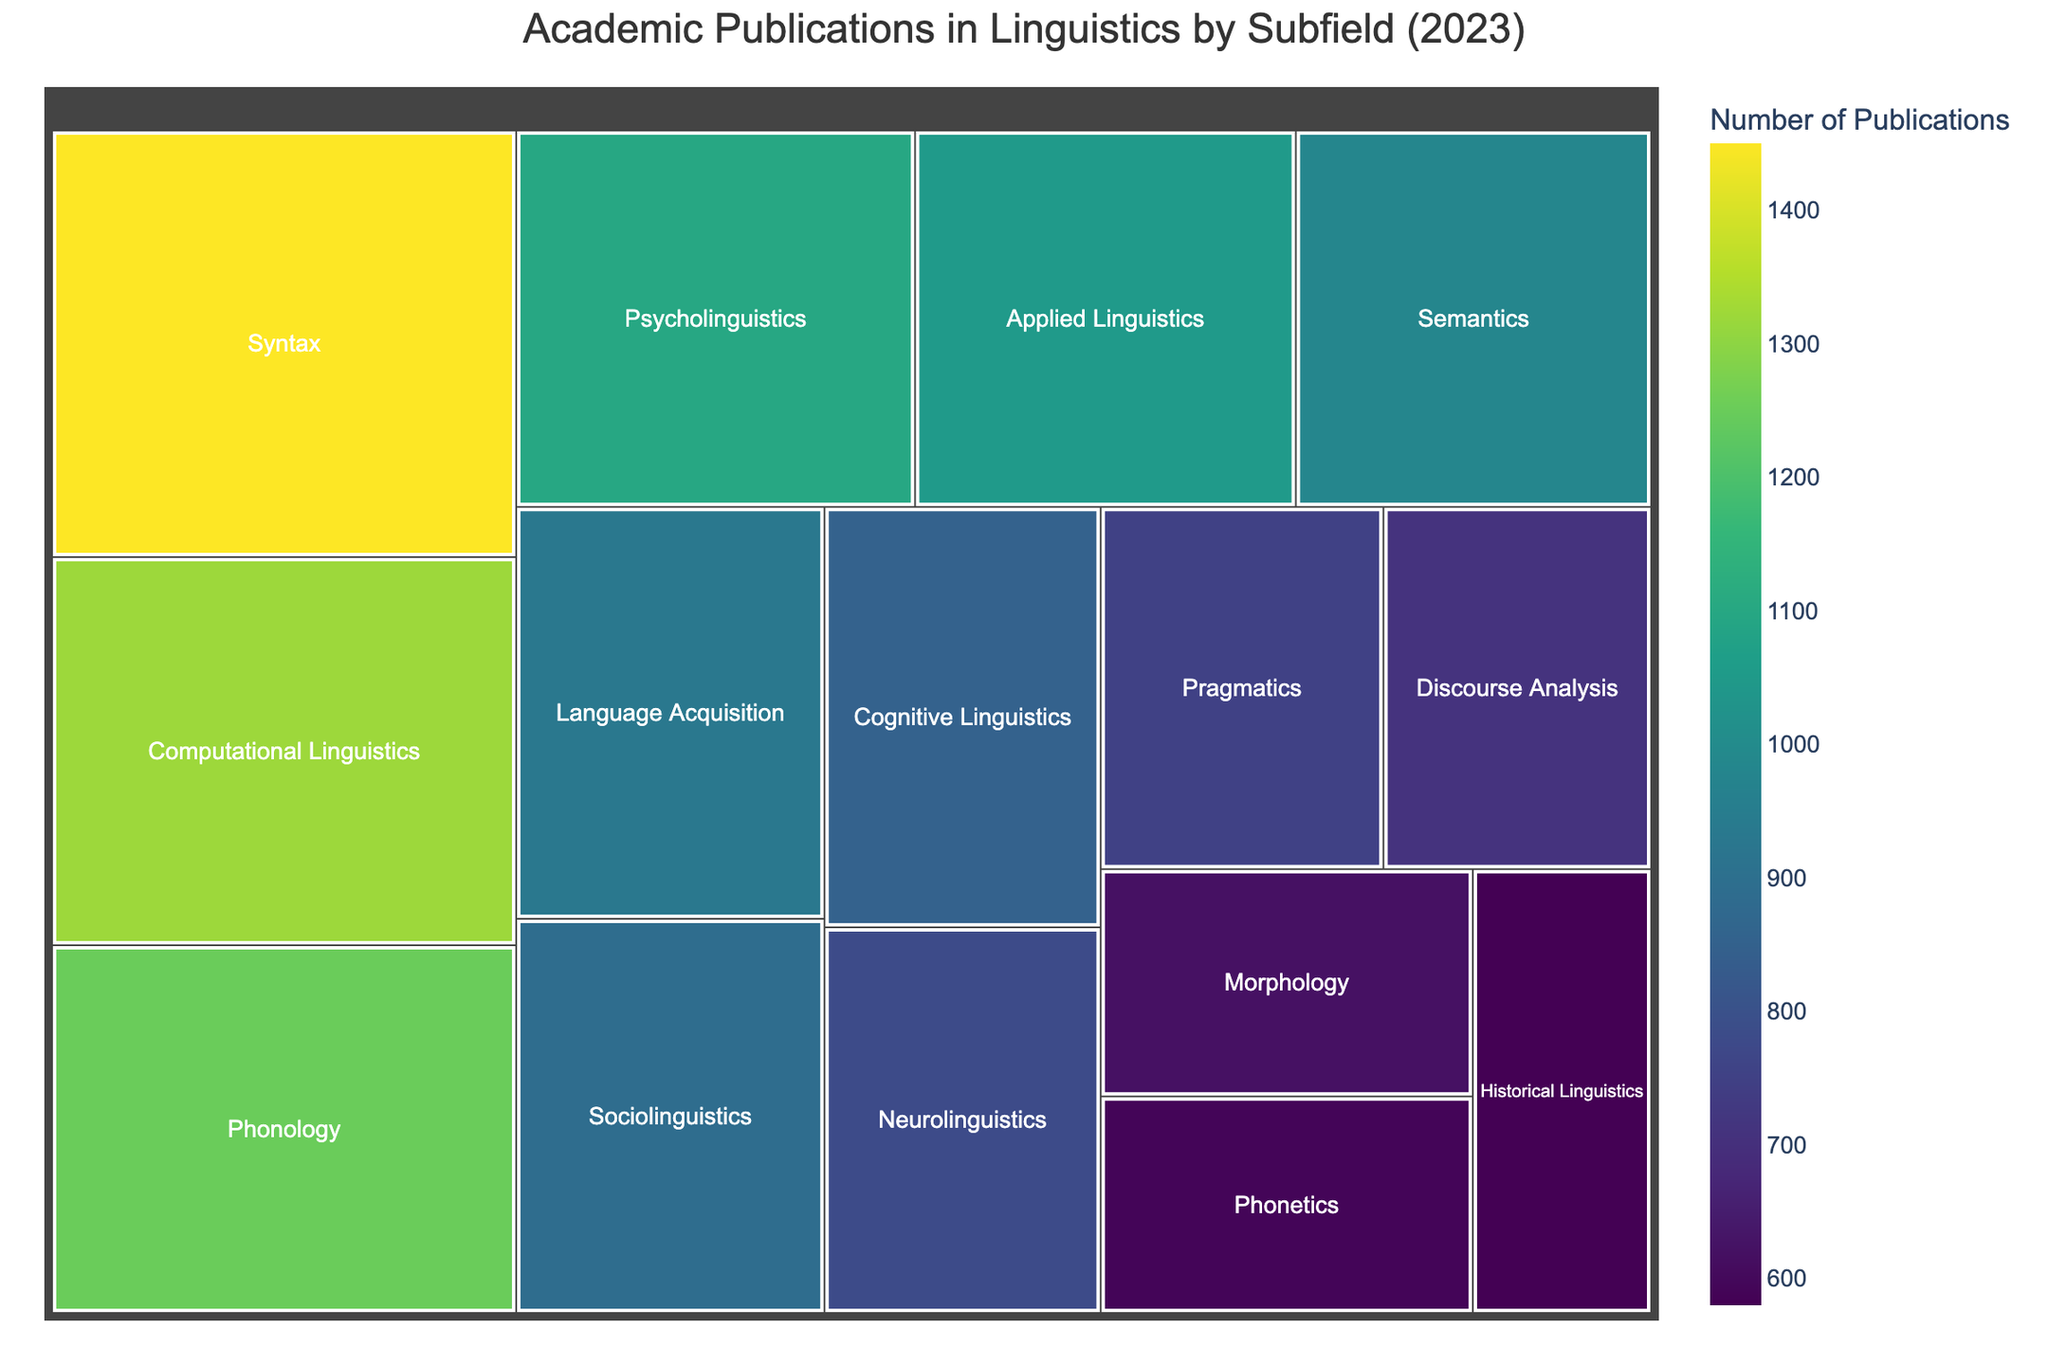what is the title of the figure? The title of the figure is indicated at the top of the treemap within the layout settings. It is written in larger font size to highlight it.
Answer: Academic Publications in Linguistics by Subfield (2023) how many publications does the Syntax subfield have? The number of publications per subfield is shown within each section of the treemap. For the Syntax subfield, this number is written on the block representing Syntax.
Answer: 1450 which subfield has the fewest publications? By inspecting the relative sizes of the blocks in the treemap, the subfield with the smallest block will have the fewest publications. This is identified as Historical Linguistics.
Answer: Historical Linguistics which subfield has more publications: Semantics or Pragmatics? By comparing the sizes and the number labels of the Semantics and Pragmatics blocks, we see that the Semantics subfield has 980 publications, whereas Pragmatics has 750 publications.
Answer: Semantics what is the total number of publications for Phonology, Syntax, and Semantics combined? Add the number of publications for Phonology (1250), Syntax (1450), and Semantics (980). (1250 + 1450 + 980) = 3680
Answer: 3680 which subfield has a greater number of publications: Computational Linguistics or Applied Linguistics? Inspect the size and labels of the blocks for the two subfields. Computational Linguistics has 1320 publications, while Applied Linguistics has 1050 publications.
Answer: Computational Linguistics what is the difference in the number of publications between Psycholinguistics and Neurolinguistics? Subtract the number of publications in Neurolinguistics (780) from those in Psycholinguistics (1100). (1100 - 780) = 320
Answer: 320 which subfield has close to 850 publications? Find the subfield blocks around 850 publications by checking the labels on the treemap and locating Cognitive Linguistics at 850 publications.
Answer: Cognitive Linguistics how does the size of the Pragmatics block compare to the Discourse Analysis block? Compare the publication numbers: Pragmatics has 750 and Discourse Analysis has 710. Pragmatics is slightly larger than Discourse Analysis.
Answer: Pragmatics what is the total number of publications for all subfields combined? Sum the number of publications for all subfields listed in the data. (1250 + 1450 + 980 + 750 + 620 + 890 + 1100 + 580 + 1320 + 1050 + 780 + 710 + 590 + 850 + 930) = 13850
Answer: 13850 